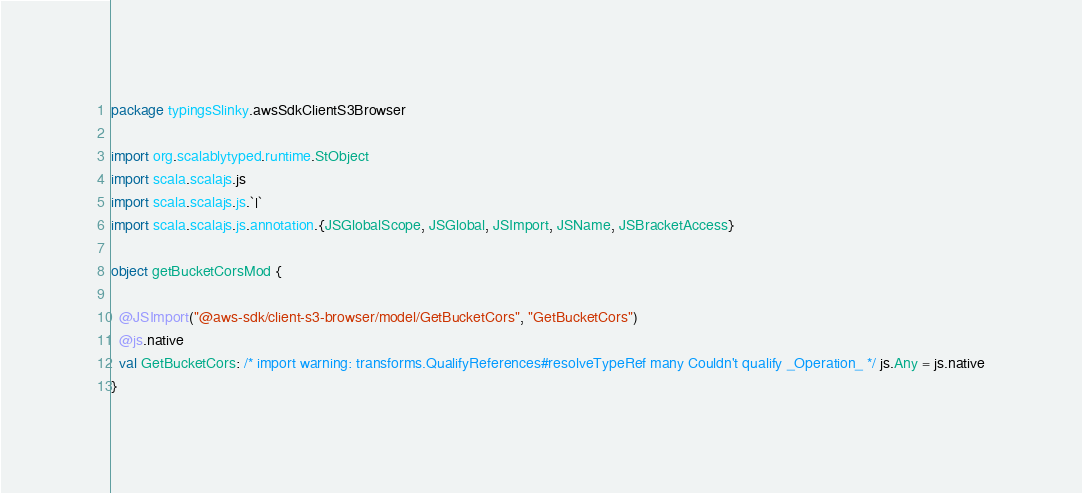<code> <loc_0><loc_0><loc_500><loc_500><_Scala_>package typingsSlinky.awsSdkClientS3Browser

import org.scalablytyped.runtime.StObject
import scala.scalajs.js
import scala.scalajs.js.`|`
import scala.scalajs.js.annotation.{JSGlobalScope, JSGlobal, JSImport, JSName, JSBracketAccess}

object getBucketCorsMod {
  
  @JSImport("@aws-sdk/client-s3-browser/model/GetBucketCors", "GetBucketCors")
  @js.native
  val GetBucketCors: /* import warning: transforms.QualifyReferences#resolveTypeRef many Couldn't qualify _Operation_ */ js.Any = js.native
}
</code> 